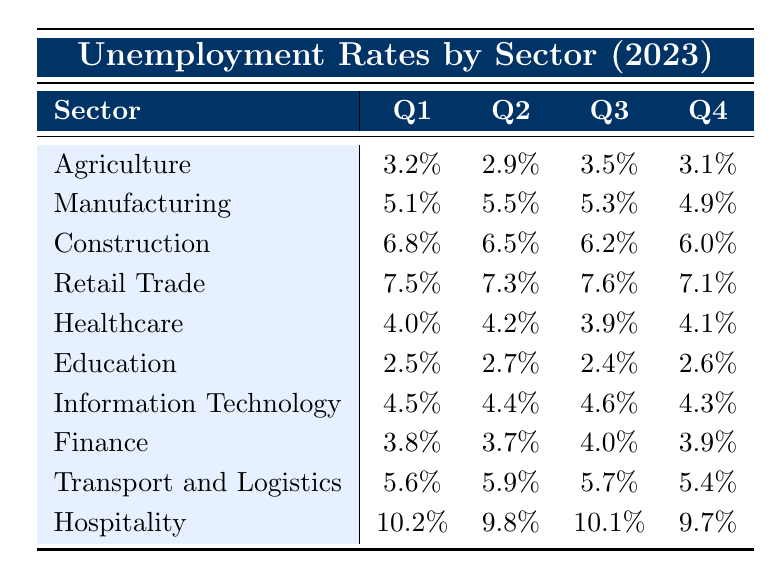What was the unemployment rate in the Manufacturing sector during Q3? The table shows that the unemployment rate for Manufacturing in Q3 is listed directly under the Q3 column, which is 5.3%.
Answer: 5.3% Which sector had the highest unemployment rate in Q1? By looking at the Q1 values in the table, Hospitality has the highest unemployment rate at 10.2%.
Answer: Hospitality What is the average unemployment rate for the Education sector across all quarters? The rates for Education across the quarters are 2.5%, 2.7%, 2.4%, and 2.6%. Average is calculated as (2.5 + 2.7 + 2.4 + 2.6) / 4 = 2.575%.
Answer: 2.575% Did the unemployment rate in the Agriculture sector increase or decrease from Q2 to Q3? The unemployment rate in Agriculture went from 2.9% in Q2 to 3.5% in Q3, which indicates an increase.
Answer: Increase What was the difference in unemployment rates between the Healthcare and Manufacturing sectors in Q4? The unemployment rate for Healthcare in Q4 is 4.1% and for Manufacturing is 4.9%. The difference is 4.9% - 4.1% = 0.8%.
Answer: 0.8% What percentage of the sectors had an unemployment rate higher than 6% in Q1? In Q1, the sectors with rates higher than 6% are Construction (6.8%), Retail Trade (7.5%), and Hospitality (10.2%). There are 3 sectors out of 10, so the percentage is (3/10) * 100 = 30%.
Answer: 30% Is it true that the unemployment rate in the Transport and Logistics sector was lower in Q4 than in Q3? In the table, the rate for Transport and Logistics in Q4 is 5.4%, while in Q3 it is 5.7%. Since 5.4% is lower than 5.7%, the statement is true.
Answer: True What is the overall trend in unemployment rates for the Manufacturing sector across the year? By examining the quarterly rates for Manufacturing (5.1%, 5.5%, 5.3%, 4.9%), we can see that it initially increased from Q1 to Q2, then slightly decreased in Q3 and further in Q4. Overall, this indicates a downward trend by the end of the year.
Answer: Downward trend Which sector has the most stable unemployment rates across the four quarters? To determine stability, we look at the variance of each sector's unemployment rates. Education has the least fluctuation with rates of 2.5%, 2.7%, 2.4%, and 2.6%, showing minimal variation.
Answer: Education How many sectors had unemployment rates of 4% or less in Q2? Analyzing Q2, the sectors with rates of 4% or less are Agriculture (2.9%), Education (2.7%), and Finance (3.7%). That makes a total of 3 sectors.
Answer: 3 